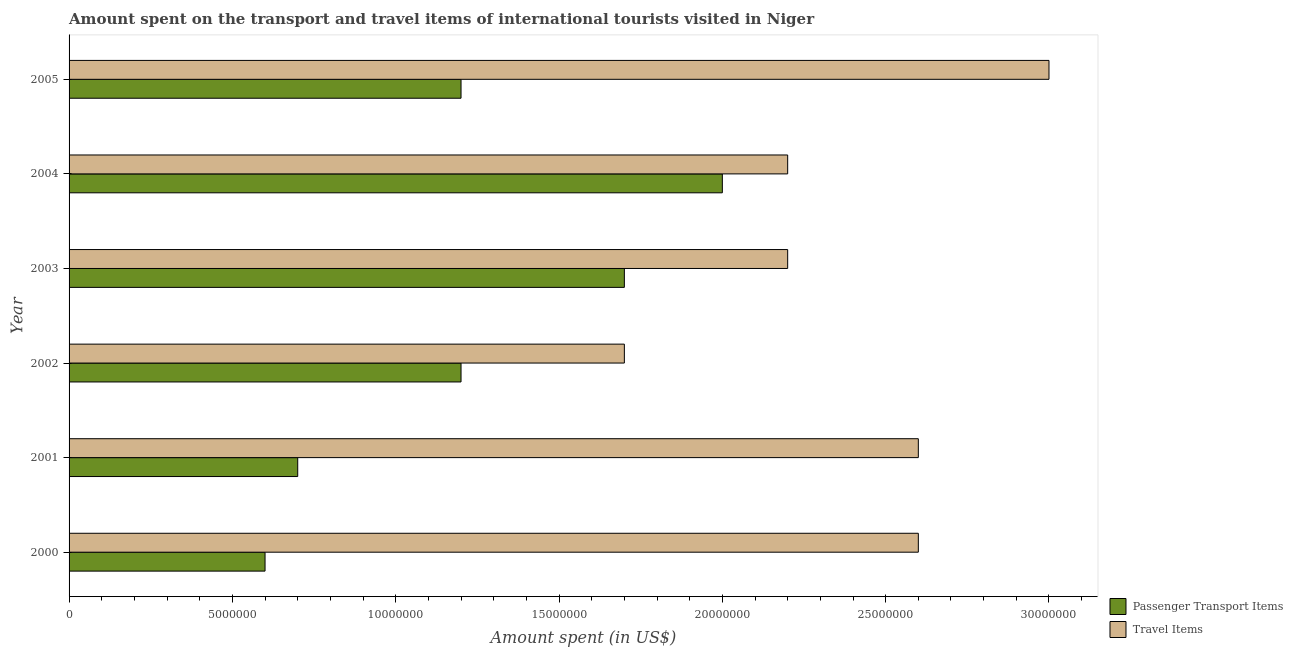How many different coloured bars are there?
Ensure brevity in your answer.  2. Are the number of bars per tick equal to the number of legend labels?
Offer a terse response. Yes. How many bars are there on the 3rd tick from the bottom?
Provide a short and direct response. 2. In how many cases, is the number of bars for a given year not equal to the number of legend labels?
Make the answer very short. 0. What is the amount spent in travel items in 2003?
Offer a terse response. 2.20e+07. Across all years, what is the maximum amount spent in travel items?
Offer a terse response. 3.00e+07. Across all years, what is the minimum amount spent on passenger transport items?
Offer a terse response. 6.00e+06. In which year was the amount spent on passenger transport items minimum?
Ensure brevity in your answer.  2000. What is the total amount spent in travel items in the graph?
Keep it short and to the point. 1.43e+08. What is the difference between the amount spent on passenger transport items in 2000 and that in 2004?
Your response must be concise. -1.40e+07. What is the difference between the amount spent on passenger transport items in 2003 and the amount spent in travel items in 2000?
Give a very brief answer. -9.00e+06. What is the average amount spent in travel items per year?
Your answer should be very brief. 2.38e+07. In the year 2003, what is the difference between the amount spent in travel items and amount spent on passenger transport items?
Your response must be concise. 5.00e+06. In how many years, is the amount spent on passenger transport items greater than 13000000 US$?
Make the answer very short. 2. What is the ratio of the amount spent on passenger transport items in 2001 to that in 2003?
Give a very brief answer. 0.41. Is the amount spent in travel items in 2000 less than that in 2001?
Provide a short and direct response. No. Is the difference between the amount spent in travel items in 2000 and 2002 greater than the difference between the amount spent on passenger transport items in 2000 and 2002?
Provide a succinct answer. Yes. What is the difference between the highest and the lowest amount spent in travel items?
Your answer should be compact. 1.30e+07. In how many years, is the amount spent in travel items greater than the average amount spent in travel items taken over all years?
Offer a very short reply. 3. What does the 2nd bar from the top in 2004 represents?
Offer a very short reply. Passenger Transport Items. What does the 1st bar from the bottom in 2000 represents?
Keep it short and to the point. Passenger Transport Items. What is the difference between two consecutive major ticks on the X-axis?
Make the answer very short. 5.00e+06. Are the values on the major ticks of X-axis written in scientific E-notation?
Give a very brief answer. No. Does the graph contain any zero values?
Your answer should be compact. No. Where does the legend appear in the graph?
Provide a succinct answer. Bottom right. What is the title of the graph?
Offer a very short reply. Amount spent on the transport and travel items of international tourists visited in Niger. What is the label or title of the X-axis?
Your answer should be very brief. Amount spent (in US$). What is the label or title of the Y-axis?
Offer a very short reply. Year. What is the Amount spent (in US$) in Passenger Transport Items in 2000?
Offer a very short reply. 6.00e+06. What is the Amount spent (in US$) of Travel Items in 2000?
Offer a very short reply. 2.60e+07. What is the Amount spent (in US$) of Passenger Transport Items in 2001?
Ensure brevity in your answer.  7.00e+06. What is the Amount spent (in US$) in Travel Items in 2001?
Provide a succinct answer. 2.60e+07. What is the Amount spent (in US$) in Travel Items in 2002?
Your response must be concise. 1.70e+07. What is the Amount spent (in US$) of Passenger Transport Items in 2003?
Your answer should be very brief. 1.70e+07. What is the Amount spent (in US$) of Travel Items in 2003?
Your answer should be very brief. 2.20e+07. What is the Amount spent (in US$) in Passenger Transport Items in 2004?
Your answer should be compact. 2.00e+07. What is the Amount spent (in US$) in Travel Items in 2004?
Keep it short and to the point. 2.20e+07. What is the Amount spent (in US$) of Passenger Transport Items in 2005?
Offer a very short reply. 1.20e+07. What is the Amount spent (in US$) in Travel Items in 2005?
Your answer should be compact. 3.00e+07. Across all years, what is the maximum Amount spent (in US$) in Passenger Transport Items?
Provide a succinct answer. 2.00e+07. Across all years, what is the maximum Amount spent (in US$) in Travel Items?
Your answer should be very brief. 3.00e+07. Across all years, what is the minimum Amount spent (in US$) in Passenger Transport Items?
Provide a succinct answer. 6.00e+06. Across all years, what is the minimum Amount spent (in US$) in Travel Items?
Your response must be concise. 1.70e+07. What is the total Amount spent (in US$) of Passenger Transport Items in the graph?
Ensure brevity in your answer.  7.40e+07. What is the total Amount spent (in US$) of Travel Items in the graph?
Your answer should be very brief. 1.43e+08. What is the difference between the Amount spent (in US$) of Passenger Transport Items in 2000 and that in 2002?
Provide a succinct answer. -6.00e+06. What is the difference between the Amount spent (in US$) of Travel Items in 2000 and that in 2002?
Your answer should be compact. 9.00e+06. What is the difference between the Amount spent (in US$) of Passenger Transport Items in 2000 and that in 2003?
Provide a succinct answer. -1.10e+07. What is the difference between the Amount spent (in US$) of Travel Items in 2000 and that in 2003?
Your answer should be compact. 4.00e+06. What is the difference between the Amount spent (in US$) of Passenger Transport Items in 2000 and that in 2004?
Your response must be concise. -1.40e+07. What is the difference between the Amount spent (in US$) of Travel Items in 2000 and that in 2004?
Make the answer very short. 4.00e+06. What is the difference between the Amount spent (in US$) in Passenger Transport Items in 2000 and that in 2005?
Keep it short and to the point. -6.00e+06. What is the difference between the Amount spent (in US$) in Passenger Transport Items in 2001 and that in 2002?
Offer a terse response. -5.00e+06. What is the difference between the Amount spent (in US$) of Travel Items in 2001 and that in 2002?
Make the answer very short. 9.00e+06. What is the difference between the Amount spent (in US$) of Passenger Transport Items in 2001 and that in 2003?
Provide a succinct answer. -1.00e+07. What is the difference between the Amount spent (in US$) in Passenger Transport Items in 2001 and that in 2004?
Your answer should be compact. -1.30e+07. What is the difference between the Amount spent (in US$) of Passenger Transport Items in 2001 and that in 2005?
Provide a short and direct response. -5.00e+06. What is the difference between the Amount spent (in US$) of Passenger Transport Items in 2002 and that in 2003?
Your answer should be compact. -5.00e+06. What is the difference between the Amount spent (in US$) of Travel Items in 2002 and that in 2003?
Make the answer very short. -5.00e+06. What is the difference between the Amount spent (in US$) in Passenger Transport Items in 2002 and that in 2004?
Offer a terse response. -8.00e+06. What is the difference between the Amount spent (in US$) in Travel Items in 2002 and that in 2004?
Offer a very short reply. -5.00e+06. What is the difference between the Amount spent (in US$) in Travel Items in 2002 and that in 2005?
Provide a succinct answer. -1.30e+07. What is the difference between the Amount spent (in US$) of Passenger Transport Items in 2003 and that in 2004?
Ensure brevity in your answer.  -3.00e+06. What is the difference between the Amount spent (in US$) in Travel Items in 2003 and that in 2005?
Provide a succinct answer. -8.00e+06. What is the difference between the Amount spent (in US$) in Travel Items in 2004 and that in 2005?
Offer a very short reply. -8.00e+06. What is the difference between the Amount spent (in US$) of Passenger Transport Items in 2000 and the Amount spent (in US$) of Travel Items in 2001?
Keep it short and to the point. -2.00e+07. What is the difference between the Amount spent (in US$) in Passenger Transport Items in 2000 and the Amount spent (in US$) in Travel Items in 2002?
Your answer should be very brief. -1.10e+07. What is the difference between the Amount spent (in US$) in Passenger Transport Items in 2000 and the Amount spent (in US$) in Travel Items in 2003?
Keep it short and to the point. -1.60e+07. What is the difference between the Amount spent (in US$) of Passenger Transport Items in 2000 and the Amount spent (in US$) of Travel Items in 2004?
Give a very brief answer. -1.60e+07. What is the difference between the Amount spent (in US$) in Passenger Transport Items in 2000 and the Amount spent (in US$) in Travel Items in 2005?
Offer a terse response. -2.40e+07. What is the difference between the Amount spent (in US$) in Passenger Transport Items in 2001 and the Amount spent (in US$) in Travel Items in 2002?
Make the answer very short. -1.00e+07. What is the difference between the Amount spent (in US$) in Passenger Transport Items in 2001 and the Amount spent (in US$) in Travel Items in 2003?
Make the answer very short. -1.50e+07. What is the difference between the Amount spent (in US$) of Passenger Transport Items in 2001 and the Amount spent (in US$) of Travel Items in 2004?
Your answer should be compact. -1.50e+07. What is the difference between the Amount spent (in US$) of Passenger Transport Items in 2001 and the Amount spent (in US$) of Travel Items in 2005?
Provide a succinct answer. -2.30e+07. What is the difference between the Amount spent (in US$) in Passenger Transport Items in 2002 and the Amount spent (in US$) in Travel Items in 2003?
Offer a terse response. -1.00e+07. What is the difference between the Amount spent (in US$) in Passenger Transport Items in 2002 and the Amount spent (in US$) in Travel Items in 2004?
Provide a short and direct response. -1.00e+07. What is the difference between the Amount spent (in US$) in Passenger Transport Items in 2002 and the Amount spent (in US$) in Travel Items in 2005?
Offer a terse response. -1.80e+07. What is the difference between the Amount spent (in US$) in Passenger Transport Items in 2003 and the Amount spent (in US$) in Travel Items in 2004?
Your answer should be compact. -5.00e+06. What is the difference between the Amount spent (in US$) in Passenger Transport Items in 2003 and the Amount spent (in US$) in Travel Items in 2005?
Ensure brevity in your answer.  -1.30e+07. What is the difference between the Amount spent (in US$) in Passenger Transport Items in 2004 and the Amount spent (in US$) in Travel Items in 2005?
Your answer should be compact. -1.00e+07. What is the average Amount spent (in US$) in Passenger Transport Items per year?
Offer a terse response. 1.23e+07. What is the average Amount spent (in US$) of Travel Items per year?
Ensure brevity in your answer.  2.38e+07. In the year 2000, what is the difference between the Amount spent (in US$) of Passenger Transport Items and Amount spent (in US$) of Travel Items?
Provide a short and direct response. -2.00e+07. In the year 2001, what is the difference between the Amount spent (in US$) of Passenger Transport Items and Amount spent (in US$) of Travel Items?
Offer a terse response. -1.90e+07. In the year 2002, what is the difference between the Amount spent (in US$) in Passenger Transport Items and Amount spent (in US$) in Travel Items?
Your response must be concise. -5.00e+06. In the year 2003, what is the difference between the Amount spent (in US$) in Passenger Transport Items and Amount spent (in US$) in Travel Items?
Keep it short and to the point. -5.00e+06. In the year 2005, what is the difference between the Amount spent (in US$) of Passenger Transport Items and Amount spent (in US$) of Travel Items?
Give a very brief answer. -1.80e+07. What is the ratio of the Amount spent (in US$) in Passenger Transport Items in 2000 to that in 2001?
Offer a terse response. 0.86. What is the ratio of the Amount spent (in US$) of Travel Items in 2000 to that in 2001?
Make the answer very short. 1. What is the ratio of the Amount spent (in US$) of Travel Items in 2000 to that in 2002?
Keep it short and to the point. 1.53. What is the ratio of the Amount spent (in US$) of Passenger Transport Items in 2000 to that in 2003?
Provide a succinct answer. 0.35. What is the ratio of the Amount spent (in US$) in Travel Items in 2000 to that in 2003?
Give a very brief answer. 1.18. What is the ratio of the Amount spent (in US$) of Travel Items in 2000 to that in 2004?
Your answer should be very brief. 1.18. What is the ratio of the Amount spent (in US$) of Travel Items in 2000 to that in 2005?
Your answer should be very brief. 0.87. What is the ratio of the Amount spent (in US$) of Passenger Transport Items in 2001 to that in 2002?
Your answer should be compact. 0.58. What is the ratio of the Amount spent (in US$) of Travel Items in 2001 to that in 2002?
Offer a very short reply. 1.53. What is the ratio of the Amount spent (in US$) in Passenger Transport Items in 2001 to that in 2003?
Your answer should be compact. 0.41. What is the ratio of the Amount spent (in US$) of Travel Items in 2001 to that in 2003?
Give a very brief answer. 1.18. What is the ratio of the Amount spent (in US$) of Passenger Transport Items in 2001 to that in 2004?
Your response must be concise. 0.35. What is the ratio of the Amount spent (in US$) of Travel Items in 2001 to that in 2004?
Provide a succinct answer. 1.18. What is the ratio of the Amount spent (in US$) of Passenger Transport Items in 2001 to that in 2005?
Ensure brevity in your answer.  0.58. What is the ratio of the Amount spent (in US$) in Travel Items in 2001 to that in 2005?
Your response must be concise. 0.87. What is the ratio of the Amount spent (in US$) in Passenger Transport Items in 2002 to that in 2003?
Your response must be concise. 0.71. What is the ratio of the Amount spent (in US$) of Travel Items in 2002 to that in 2003?
Your answer should be very brief. 0.77. What is the ratio of the Amount spent (in US$) of Travel Items in 2002 to that in 2004?
Offer a very short reply. 0.77. What is the ratio of the Amount spent (in US$) in Passenger Transport Items in 2002 to that in 2005?
Your answer should be compact. 1. What is the ratio of the Amount spent (in US$) in Travel Items in 2002 to that in 2005?
Offer a terse response. 0.57. What is the ratio of the Amount spent (in US$) in Passenger Transport Items in 2003 to that in 2004?
Ensure brevity in your answer.  0.85. What is the ratio of the Amount spent (in US$) of Travel Items in 2003 to that in 2004?
Offer a terse response. 1. What is the ratio of the Amount spent (in US$) in Passenger Transport Items in 2003 to that in 2005?
Your answer should be very brief. 1.42. What is the ratio of the Amount spent (in US$) in Travel Items in 2003 to that in 2005?
Your response must be concise. 0.73. What is the ratio of the Amount spent (in US$) of Travel Items in 2004 to that in 2005?
Ensure brevity in your answer.  0.73. What is the difference between the highest and the lowest Amount spent (in US$) of Passenger Transport Items?
Offer a very short reply. 1.40e+07. What is the difference between the highest and the lowest Amount spent (in US$) of Travel Items?
Your answer should be compact. 1.30e+07. 